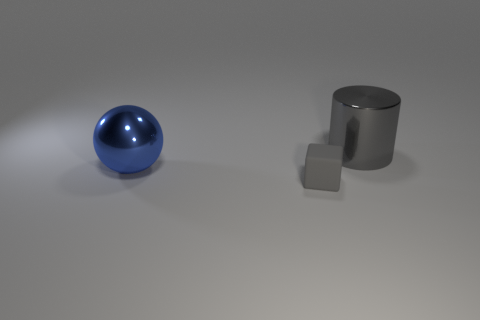There is a object that is in front of the big blue metal sphere; does it have the same shape as the large blue object?
Ensure brevity in your answer.  No. What is the shape of the object that is behind the blue sphere that is to the left of the cylinder?
Provide a short and direct response. Cylinder. Are there any other things that are the same shape as the big gray object?
Provide a succinct answer. No. Is the color of the tiny block the same as the large metallic thing that is behind the metal ball?
Your response must be concise. Yes. There is a object that is in front of the metal cylinder and on the right side of the big sphere; what is its shape?
Keep it short and to the point. Cube. Is the number of large blue shiny objects less than the number of tiny green rubber cylinders?
Offer a very short reply. No. Is there a purple matte cube?
Your answer should be very brief. No. How many other things are there of the same size as the rubber thing?
Ensure brevity in your answer.  0. Are the tiny thing and the thing behind the blue shiny object made of the same material?
Provide a succinct answer. No. Are there an equal number of large gray metal things in front of the blue shiny object and things behind the gray cylinder?
Provide a short and direct response. Yes. 